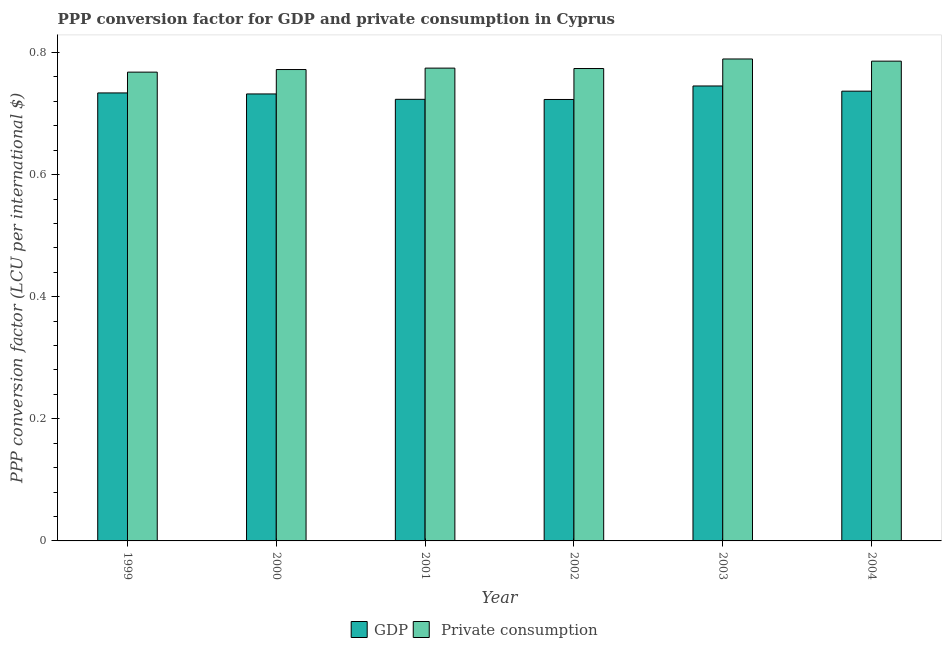How many different coloured bars are there?
Your answer should be very brief. 2. How many groups of bars are there?
Offer a very short reply. 6. Are the number of bars on each tick of the X-axis equal?
Provide a succinct answer. Yes. How many bars are there on the 5th tick from the left?
Keep it short and to the point. 2. How many bars are there on the 3rd tick from the right?
Make the answer very short. 2. What is the label of the 2nd group of bars from the left?
Provide a succinct answer. 2000. What is the ppp conversion factor for private consumption in 1999?
Give a very brief answer. 0.77. Across all years, what is the maximum ppp conversion factor for gdp?
Your answer should be very brief. 0.75. Across all years, what is the minimum ppp conversion factor for gdp?
Your response must be concise. 0.72. In which year was the ppp conversion factor for private consumption minimum?
Make the answer very short. 1999. What is the total ppp conversion factor for gdp in the graph?
Provide a succinct answer. 4.39. What is the difference between the ppp conversion factor for private consumption in 2000 and that in 2002?
Keep it short and to the point. -0. What is the difference between the ppp conversion factor for gdp in 2001 and the ppp conversion factor for private consumption in 2002?
Your answer should be compact. 0. What is the average ppp conversion factor for gdp per year?
Offer a very short reply. 0.73. In the year 2003, what is the difference between the ppp conversion factor for private consumption and ppp conversion factor for gdp?
Your answer should be compact. 0. What is the ratio of the ppp conversion factor for private consumption in 2002 to that in 2003?
Your answer should be compact. 0.98. Is the difference between the ppp conversion factor for gdp in 2001 and 2003 greater than the difference between the ppp conversion factor for private consumption in 2001 and 2003?
Offer a terse response. No. What is the difference between the highest and the second highest ppp conversion factor for private consumption?
Your answer should be compact. 0. What is the difference between the highest and the lowest ppp conversion factor for private consumption?
Provide a succinct answer. 0.02. In how many years, is the ppp conversion factor for gdp greater than the average ppp conversion factor for gdp taken over all years?
Make the answer very short. 3. Is the sum of the ppp conversion factor for private consumption in 2000 and 2002 greater than the maximum ppp conversion factor for gdp across all years?
Keep it short and to the point. Yes. What does the 1st bar from the left in 2004 represents?
Make the answer very short. GDP. What does the 1st bar from the right in 2004 represents?
Offer a very short reply.  Private consumption. How many bars are there?
Provide a short and direct response. 12. How many years are there in the graph?
Give a very brief answer. 6. What is the difference between two consecutive major ticks on the Y-axis?
Give a very brief answer. 0.2. Where does the legend appear in the graph?
Provide a succinct answer. Bottom center. How many legend labels are there?
Provide a short and direct response. 2. What is the title of the graph?
Give a very brief answer. PPP conversion factor for GDP and private consumption in Cyprus. Does "By country of origin" appear as one of the legend labels in the graph?
Your response must be concise. No. What is the label or title of the Y-axis?
Offer a terse response. PPP conversion factor (LCU per international $). What is the PPP conversion factor (LCU per international $) in GDP in 1999?
Keep it short and to the point. 0.73. What is the PPP conversion factor (LCU per international $) of  Private consumption in 1999?
Give a very brief answer. 0.77. What is the PPP conversion factor (LCU per international $) in GDP in 2000?
Your answer should be compact. 0.73. What is the PPP conversion factor (LCU per international $) of  Private consumption in 2000?
Your answer should be compact. 0.77. What is the PPP conversion factor (LCU per international $) of GDP in 2001?
Your answer should be very brief. 0.72. What is the PPP conversion factor (LCU per international $) in  Private consumption in 2001?
Your response must be concise. 0.77. What is the PPP conversion factor (LCU per international $) in GDP in 2002?
Your response must be concise. 0.72. What is the PPP conversion factor (LCU per international $) of  Private consumption in 2002?
Provide a short and direct response. 0.77. What is the PPP conversion factor (LCU per international $) in GDP in 2003?
Provide a short and direct response. 0.75. What is the PPP conversion factor (LCU per international $) in  Private consumption in 2003?
Ensure brevity in your answer.  0.79. What is the PPP conversion factor (LCU per international $) of GDP in 2004?
Provide a succinct answer. 0.74. What is the PPP conversion factor (LCU per international $) of  Private consumption in 2004?
Ensure brevity in your answer.  0.79. Across all years, what is the maximum PPP conversion factor (LCU per international $) in GDP?
Make the answer very short. 0.75. Across all years, what is the maximum PPP conversion factor (LCU per international $) in  Private consumption?
Your response must be concise. 0.79. Across all years, what is the minimum PPP conversion factor (LCU per international $) in GDP?
Your response must be concise. 0.72. Across all years, what is the minimum PPP conversion factor (LCU per international $) of  Private consumption?
Make the answer very short. 0.77. What is the total PPP conversion factor (LCU per international $) in GDP in the graph?
Keep it short and to the point. 4.39. What is the total PPP conversion factor (LCU per international $) of  Private consumption in the graph?
Ensure brevity in your answer.  4.66. What is the difference between the PPP conversion factor (LCU per international $) in GDP in 1999 and that in 2000?
Keep it short and to the point. 0. What is the difference between the PPP conversion factor (LCU per international $) in  Private consumption in 1999 and that in 2000?
Offer a terse response. -0. What is the difference between the PPP conversion factor (LCU per international $) of GDP in 1999 and that in 2001?
Keep it short and to the point. 0.01. What is the difference between the PPP conversion factor (LCU per international $) in  Private consumption in 1999 and that in 2001?
Your answer should be very brief. -0.01. What is the difference between the PPP conversion factor (LCU per international $) of GDP in 1999 and that in 2002?
Give a very brief answer. 0.01. What is the difference between the PPP conversion factor (LCU per international $) in  Private consumption in 1999 and that in 2002?
Your response must be concise. -0.01. What is the difference between the PPP conversion factor (LCU per international $) of GDP in 1999 and that in 2003?
Ensure brevity in your answer.  -0.01. What is the difference between the PPP conversion factor (LCU per international $) of  Private consumption in 1999 and that in 2003?
Ensure brevity in your answer.  -0.02. What is the difference between the PPP conversion factor (LCU per international $) in GDP in 1999 and that in 2004?
Your answer should be very brief. -0. What is the difference between the PPP conversion factor (LCU per international $) of  Private consumption in 1999 and that in 2004?
Your answer should be very brief. -0.02. What is the difference between the PPP conversion factor (LCU per international $) in GDP in 2000 and that in 2001?
Your answer should be compact. 0.01. What is the difference between the PPP conversion factor (LCU per international $) of  Private consumption in 2000 and that in 2001?
Ensure brevity in your answer.  -0. What is the difference between the PPP conversion factor (LCU per international $) of GDP in 2000 and that in 2002?
Offer a terse response. 0.01. What is the difference between the PPP conversion factor (LCU per international $) in  Private consumption in 2000 and that in 2002?
Offer a terse response. -0. What is the difference between the PPP conversion factor (LCU per international $) in GDP in 2000 and that in 2003?
Keep it short and to the point. -0.01. What is the difference between the PPP conversion factor (LCU per international $) in  Private consumption in 2000 and that in 2003?
Your response must be concise. -0.02. What is the difference between the PPP conversion factor (LCU per international $) of GDP in 2000 and that in 2004?
Provide a short and direct response. -0. What is the difference between the PPP conversion factor (LCU per international $) of  Private consumption in 2000 and that in 2004?
Give a very brief answer. -0.01. What is the difference between the PPP conversion factor (LCU per international $) in  Private consumption in 2001 and that in 2002?
Make the answer very short. 0. What is the difference between the PPP conversion factor (LCU per international $) of GDP in 2001 and that in 2003?
Your response must be concise. -0.02. What is the difference between the PPP conversion factor (LCU per international $) of  Private consumption in 2001 and that in 2003?
Your answer should be very brief. -0.01. What is the difference between the PPP conversion factor (LCU per international $) in GDP in 2001 and that in 2004?
Offer a terse response. -0.01. What is the difference between the PPP conversion factor (LCU per international $) in  Private consumption in 2001 and that in 2004?
Offer a very short reply. -0.01. What is the difference between the PPP conversion factor (LCU per international $) in GDP in 2002 and that in 2003?
Provide a short and direct response. -0.02. What is the difference between the PPP conversion factor (LCU per international $) in  Private consumption in 2002 and that in 2003?
Offer a terse response. -0.02. What is the difference between the PPP conversion factor (LCU per international $) of GDP in 2002 and that in 2004?
Ensure brevity in your answer.  -0.01. What is the difference between the PPP conversion factor (LCU per international $) in  Private consumption in 2002 and that in 2004?
Offer a very short reply. -0.01. What is the difference between the PPP conversion factor (LCU per international $) of GDP in 2003 and that in 2004?
Give a very brief answer. 0.01. What is the difference between the PPP conversion factor (LCU per international $) in  Private consumption in 2003 and that in 2004?
Provide a succinct answer. 0. What is the difference between the PPP conversion factor (LCU per international $) in GDP in 1999 and the PPP conversion factor (LCU per international $) in  Private consumption in 2000?
Your answer should be very brief. -0.04. What is the difference between the PPP conversion factor (LCU per international $) in GDP in 1999 and the PPP conversion factor (LCU per international $) in  Private consumption in 2001?
Ensure brevity in your answer.  -0.04. What is the difference between the PPP conversion factor (LCU per international $) of GDP in 1999 and the PPP conversion factor (LCU per international $) of  Private consumption in 2002?
Make the answer very short. -0.04. What is the difference between the PPP conversion factor (LCU per international $) in GDP in 1999 and the PPP conversion factor (LCU per international $) in  Private consumption in 2003?
Provide a short and direct response. -0.06. What is the difference between the PPP conversion factor (LCU per international $) of GDP in 1999 and the PPP conversion factor (LCU per international $) of  Private consumption in 2004?
Make the answer very short. -0.05. What is the difference between the PPP conversion factor (LCU per international $) in GDP in 2000 and the PPP conversion factor (LCU per international $) in  Private consumption in 2001?
Give a very brief answer. -0.04. What is the difference between the PPP conversion factor (LCU per international $) of GDP in 2000 and the PPP conversion factor (LCU per international $) of  Private consumption in 2002?
Keep it short and to the point. -0.04. What is the difference between the PPP conversion factor (LCU per international $) of GDP in 2000 and the PPP conversion factor (LCU per international $) of  Private consumption in 2003?
Give a very brief answer. -0.06. What is the difference between the PPP conversion factor (LCU per international $) in GDP in 2000 and the PPP conversion factor (LCU per international $) in  Private consumption in 2004?
Ensure brevity in your answer.  -0.05. What is the difference between the PPP conversion factor (LCU per international $) in GDP in 2001 and the PPP conversion factor (LCU per international $) in  Private consumption in 2002?
Your answer should be compact. -0.05. What is the difference between the PPP conversion factor (LCU per international $) in GDP in 2001 and the PPP conversion factor (LCU per international $) in  Private consumption in 2003?
Provide a succinct answer. -0.07. What is the difference between the PPP conversion factor (LCU per international $) in GDP in 2001 and the PPP conversion factor (LCU per international $) in  Private consumption in 2004?
Your response must be concise. -0.06. What is the difference between the PPP conversion factor (LCU per international $) in GDP in 2002 and the PPP conversion factor (LCU per international $) in  Private consumption in 2003?
Make the answer very short. -0.07. What is the difference between the PPP conversion factor (LCU per international $) in GDP in 2002 and the PPP conversion factor (LCU per international $) in  Private consumption in 2004?
Ensure brevity in your answer.  -0.06. What is the difference between the PPP conversion factor (LCU per international $) of GDP in 2003 and the PPP conversion factor (LCU per international $) of  Private consumption in 2004?
Provide a succinct answer. -0.04. What is the average PPP conversion factor (LCU per international $) in GDP per year?
Provide a succinct answer. 0.73. What is the average PPP conversion factor (LCU per international $) of  Private consumption per year?
Keep it short and to the point. 0.78. In the year 1999, what is the difference between the PPP conversion factor (LCU per international $) of GDP and PPP conversion factor (LCU per international $) of  Private consumption?
Your response must be concise. -0.03. In the year 2000, what is the difference between the PPP conversion factor (LCU per international $) in GDP and PPP conversion factor (LCU per international $) in  Private consumption?
Your answer should be very brief. -0.04. In the year 2001, what is the difference between the PPP conversion factor (LCU per international $) of GDP and PPP conversion factor (LCU per international $) of  Private consumption?
Your answer should be very brief. -0.05. In the year 2002, what is the difference between the PPP conversion factor (LCU per international $) of GDP and PPP conversion factor (LCU per international $) of  Private consumption?
Your answer should be very brief. -0.05. In the year 2003, what is the difference between the PPP conversion factor (LCU per international $) in GDP and PPP conversion factor (LCU per international $) in  Private consumption?
Your response must be concise. -0.04. In the year 2004, what is the difference between the PPP conversion factor (LCU per international $) in GDP and PPP conversion factor (LCU per international $) in  Private consumption?
Make the answer very short. -0.05. What is the ratio of the PPP conversion factor (LCU per international $) in  Private consumption in 1999 to that in 2000?
Your response must be concise. 0.99. What is the ratio of the PPP conversion factor (LCU per international $) of GDP in 1999 to that in 2001?
Give a very brief answer. 1.01. What is the ratio of the PPP conversion factor (LCU per international $) of GDP in 1999 to that in 2002?
Offer a terse response. 1.01. What is the ratio of the PPP conversion factor (LCU per international $) of GDP in 1999 to that in 2003?
Your answer should be very brief. 0.98. What is the ratio of the PPP conversion factor (LCU per international $) of  Private consumption in 1999 to that in 2003?
Make the answer very short. 0.97. What is the ratio of the PPP conversion factor (LCU per international $) in GDP in 1999 to that in 2004?
Give a very brief answer. 1. What is the ratio of the PPP conversion factor (LCU per international $) in  Private consumption in 1999 to that in 2004?
Provide a succinct answer. 0.98. What is the ratio of the PPP conversion factor (LCU per international $) of GDP in 2000 to that in 2001?
Offer a terse response. 1.01. What is the ratio of the PPP conversion factor (LCU per international $) of  Private consumption in 2000 to that in 2001?
Offer a terse response. 1. What is the ratio of the PPP conversion factor (LCU per international $) of GDP in 2000 to that in 2002?
Your response must be concise. 1.01. What is the ratio of the PPP conversion factor (LCU per international $) in GDP in 2000 to that in 2003?
Ensure brevity in your answer.  0.98. What is the ratio of the PPP conversion factor (LCU per international $) in  Private consumption in 2000 to that in 2003?
Provide a short and direct response. 0.98. What is the ratio of the PPP conversion factor (LCU per international $) of  Private consumption in 2000 to that in 2004?
Provide a short and direct response. 0.98. What is the ratio of the PPP conversion factor (LCU per international $) of  Private consumption in 2001 to that in 2002?
Offer a terse response. 1. What is the ratio of the PPP conversion factor (LCU per international $) of GDP in 2001 to that in 2003?
Make the answer very short. 0.97. What is the ratio of the PPP conversion factor (LCU per international $) in  Private consumption in 2001 to that in 2003?
Ensure brevity in your answer.  0.98. What is the ratio of the PPP conversion factor (LCU per international $) in GDP in 2001 to that in 2004?
Your answer should be very brief. 0.98. What is the ratio of the PPP conversion factor (LCU per international $) in  Private consumption in 2001 to that in 2004?
Offer a very short reply. 0.99. What is the ratio of the PPP conversion factor (LCU per international $) in GDP in 2002 to that in 2003?
Your answer should be very brief. 0.97. What is the ratio of the PPP conversion factor (LCU per international $) in  Private consumption in 2002 to that in 2003?
Provide a short and direct response. 0.98. What is the ratio of the PPP conversion factor (LCU per international $) in GDP in 2002 to that in 2004?
Provide a succinct answer. 0.98. What is the ratio of the PPP conversion factor (LCU per international $) of  Private consumption in 2002 to that in 2004?
Your answer should be compact. 0.98. What is the ratio of the PPP conversion factor (LCU per international $) of GDP in 2003 to that in 2004?
Provide a short and direct response. 1.01. What is the difference between the highest and the second highest PPP conversion factor (LCU per international $) of GDP?
Your answer should be very brief. 0.01. What is the difference between the highest and the second highest PPP conversion factor (LCU per international $) in  Private consumption?
Offer a very short reply. 0. What is the difference between the highest and the lowest PPP conversion factor (LCU per international $) of GDP?
Your answer should be very brief. 0.02. What is the difference between the highest and the lowest PPP conversion factor (LCU per international $) in  Private consumption?
Provide a short and direct response. 0.02. 